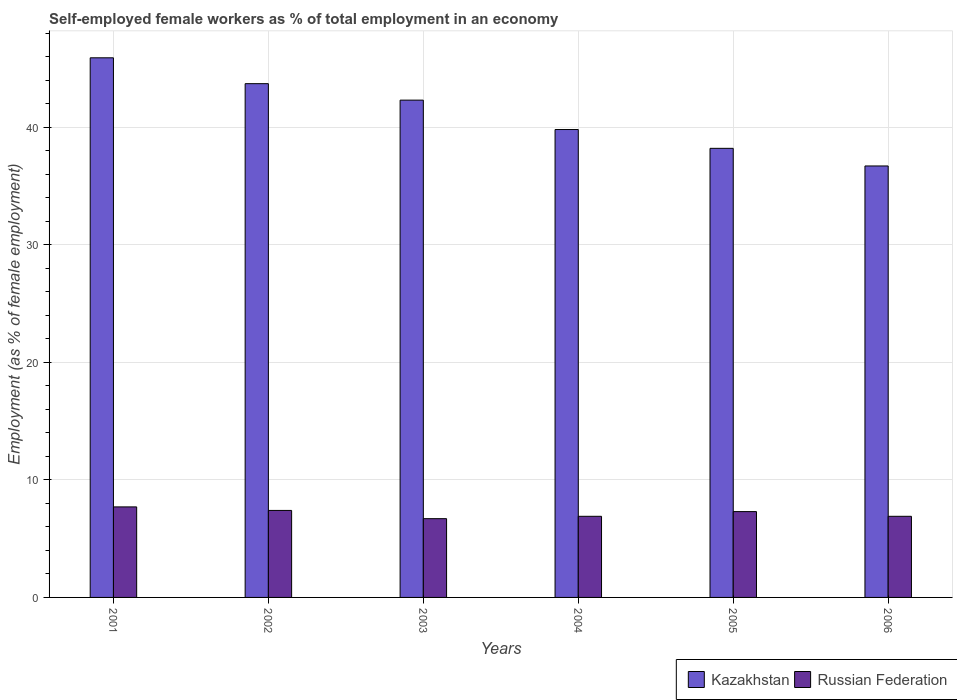How many different coloured bars are there?
Give a very brief answer. 2. How many bars are there on the 6th tick from the left?
Ensure brevity in your answer.  2. What is the percentage of self-employed female workers in Russian Federation in 2003?
Make the answer very short. 6.7. Across all years, what is the maximum percentage of self-employed female workers in Kazakhstan?
Ensure brevity in your answer.  45.9. Across all years, what is the minimum percentage of self-employed female workers in Russian Federation?
Provide a succinct answer. 6.7. In which year was the percentage of self-employed female workers in Kazakhstan maximum?
Your answer should be very brief. 2001. What is the total percentage of self-employed female workers in Kazakhstan in the graph?
Give a very brief answer. 246.6. What is the difference between the percentage of self-employed female workers in Russian Federation in 2001 and that in 2005?
Offer a very short reply. 0.4. What is the difference between the percentage of self-employed female workers in Russian Federation in 2005 and the percentage of self-employed female workers in Kazakhstan in 2006?
Your answer should be very brief. -29.4. What is the average percentage of self-employed female workers in Russian Federation per year?
Offer a terse response. 7.15. In the year 2002, what is the difference between the percentage of self-employed female workers in Russian Federation and percentage of self-employed female workers in Kazakhstan?
Your answer should be compact. -36.3. What is the ratio of the percentage of self-employed female workers in Kazakhstan in 2005 to that in 2006?
Your response must be concise. 1.04. What is the difference between the highest and the second highest percentage of self-employed female workers in Kazakhstan?
Your answer should be very brief. 2.2. What is the difference between the highest and the lowest percentage of self-employed female workers in Kazakhstan?
Ensure brevity in your answer.  9.2. In how many years, is the percentage of self-employed female workers in Kazakhstan greater than the average percentage of self-employed female workers in Kazakhstan taken over all years?
Give a very brief answer. 3. Is the sum of the percentage of self-employed female workers in Russian Federation in 2003 and 2006 greater than the maximum percentage of self-employed female workers in Kazakhstan across all years?
Your answer should be compact. No. What does the 2nd bar from the left in 2004 represents?
Your response must be concise. Russian Federation. What does the 2nd bar from the right in 2004 represents?
Keep it short and to the point. Kazakhstan. How many bars are there?
Provide a short and direct response. 12. What is the difference between two consecutive major ticks on the Y-axis?
Provide a succinct answer. 10. Are the values on the major ticks of Y-axis written in scientific E-notation?
Ensure brevity in your answer.  No. Does the graph contain any zero values?
Keep it short and to the point. No. Does the graph contain grids?
Ensure brevity in your answer.  Yes. Where does the legend appear in the graph?
Ensure brevity in your answer.  Bottom right. How many legend labels are there?
Your response must be concise. 2. What is the title of the graph?
Offer a terse response. Self-employed female workers as % of total employment in an economy. What is the label or title of the X-axis?
Give a very brief answer. Years. What is the label or title of the Y-axis?
Your answer should be compact. Employment (as % of female employment). What is the Employment (as % of female employment) of Kazakhstan in 2001?
Your answer should be compact. 45.9. What is the Employment (as % of female employment) in Russian Federation in 2001?
Give a very brief answer. 7.7. What is the Employment (as % of female employment) in Kazakhstan in 2002?
Offer a terse response. 43.7. What is the Employment (as % of female employment) of Russian Federation in 2002?
Keep it short and to the point. 7.4. What is the Employment (as % of female employment) in Kazakhstan in 2003?
Provide a succinct answer. 42.3. What is the Employment (as % of female employment) of Russian Federation in 2003?
Your answer should be very brief. 6.7. What is the Employment (as % of female employment) of Kazakhstan in 2004?
Keep it short and to the point. 39.8. What is the Employment (as % of female employment) in Russian Federation in 2004?
Your response must be concise. 6.9. What is the Employment (as % of female employment) in Kazakhstan in 2005?
Ensure brevity in your answer.  38.2. What is the Employment (as % of female employment) in Russian Federation in 2005?
Provide a succinct answer. 7.3. What is the Employment (as % of female employment) of Kazakhstan in 2006?
Keep it short and to the point. 36.7. What is the Employment (as % of female employment) of Russian Federation in 2006?
Offer a very short reply. 6.9. Across all years, what is the maximum Employment (as % of female employment) in Kazakhstan?
Your answer should be very brief. 45.9. Across all years, what is the maximum Employment (as % of female employment) of Russian Federation?
Your answer should be very brief. 7.7. Across all years, what is the minimum Employment (as % of female employment) of Kazakhstan?
Ensure brevity in your answer.  36.7. Across all years, what is the minimum Employment (as % of female employment) in Russian Federation?
Your answer should be compact. 6.7. What is the total Employment (as % of female employment) in Kazakhstan in the graph?
Your answer should be very brief. 246.6. What is the total Employment (as % of female employment) of Russian Federation in the graph?
Your answer should be compact. 42.9. What is the difference between the Employment (as % of female employment) in Russian Federation in 2001 and that in 2002?
Provide a succinct answer. 0.3. What is the difference between the Employment (as % of female employment) of Kazakhstan in 2001 and that in 2003?
Make the answer very short. 3.6. What is the difference between the Employment (as % of female employment) in Kazakhstan in 2001 and that in 2004?
Your answer should be compact. 6.1. What is the difference between the Employment (as % of female employment) in Kazakhstan in 2001 and that in 2005?
Your answer should be very brief. 7.7. What is the difference between the Employment (as % of female employment) of Kazakhstan in 2002 and that in 2003?
Keep it short and to the point. 1.4. What is the difference between the Employment (as % of female employment) in Russian Federation in 2002 and that in 2004?
Your answer should be very brief. 0.5. What is the difference between the Employment (as % of female employment) of Kazakhstan in 2002 and that in 2005?
Your response must be concise. 5.5. What is the difference between the Employment (as % of female employment) of Russian Federation in 2002 and that in 2005?
Give a very brief answer. 0.1. What is the difference between the Employment (as % of female employment) in Kazakhstan in 2002 and that in 2006?
Give a very brief answer. 7. What is the difference between the Employment (as % of female employment) of Russian Federation in 2002 and that in 2006?
Offer a very short reply. 0.5. What is the difference between the Employment (as % of female employment) in Kazakhstan in 2003 and that in 2004?
Offer a very short reply. 2.5. What is the difference between the Employment (as % of female employment) in Russian Federation in 2003 and that in 2004?
Ensure brevity in your answer.  -0.2. What is the difference between the Employment (as % of female employment) of Russian Federation in 2003 and that in 2005?
Provide a succinct answer. -0.6. What is the difference between the Employment (as % of female employment) of Russian Federation in 2003 and that in 2006?
Your response must be concise. -0.2. What is the difference between the Employment (as % of female employment) in Russian Federation in 2004 and that in 2006?
Give a very brief answer. 0. What is the difference between the Employment (as % of female employment) of Kazakhstan in 2005 and that in 2006?
Provide a succinct answer. 1.5. What is the difference between the Employment (as % of female employment) in Kazakhstan in 2001 and the Employment (as % of female employment) in Russian Federation in 2002?
Provide a succinct answer. 38.5. What is the difference between the Employment (as % of female employment) in Kazakhstan in 2001 and the Employment (as % of female employment) in Russian Federation in 2003?
Offer a terse response. 39.2. What is the difference between the Employment (as % of female employment) in Kazakhstan in 2001 and the Employment (as % of female employment) in Russian Federation in 2005?
Make the answer very short. 38.6. What is the difference between the Employment (as % of female employment) in Kazakhstan in 2002 and the Employment (as % of female employment) in Russian Federation in 2004?
Your answer should be very brief. 36.8. What is the difference between the Employment (as % of female employment) in Kazakhstan in 2002 and the Employment (as % of female employment) in Russian Federation in 2005?
Provide a succinct answer. 36.4. What is the difference between the Employment (as % of female employment) of Kazakhstan in 2002 and the Employment (as % of female employment) of Russian Federation in 2006?
Your response must be concise. 36.8. What is the difference between the Employment (as % of female employment) in Kazakhstan in 2003 and the Employment (as % of female employment) in Russian Federation in 2004?
Give a very brief answer. 35.4. What is the difference between the Employment (as % of female employment) in Kazakhstan in 2003 and the Employment (as % of female employment) in Russian Federation in 2006?
Offer a very short reply. 35.4. What is the difference between the Employment (as % of female employment) of Kazakhstan in 2004 and the Employment (as % of female employment) of Russian Federation in 2005?
Ensure brevity in your answer.  32.5. What is the difference between the Employment (as % of female employment) of Kazakhstan in 2004 and the Employment (as % of female employment) of Russian Federation in 2006?
Your response must be concise. 32.9. What is the difference between the Employment (as % of female employment) of Kazakhstan in 2005 and the Employment (as % of female employment) of Russian Federation in 2006?
Ensure brevity in your answer.  31.3. What is the average Employment (as % of female employment) in Kazakhstan per year?
Ensure brevity in your answer.  41.1. What is the average Employment (as % of female employment) of Russian Federation per year?
Give a very brief answer. 7.15. In the year 2001, what is the difference between the Employment (as % of female employment) in Kazakhstan and Employment (as % of female employment) in Russian Federation?
Make the answer very short. 38.2. In the year 2002, what is the difference between the Employment (as % of female employment) of Kazakhstan and Employment (as % of female employment) of Russian Federation?
Ensure brevity in your answer.  36.3. In the year 2003, what is the difference between the Employment (as % of female employment) of Kazakhstan and Employment (as % of female employment) of Russian Federation?
Your answer should be compact. 35.6. In the year 2004, what is the difference between the Employment (as % of female employment) in Kazakhstan and Employment (as % of female employment) in Russian Federation?
Ensure brevity in your answer.  32.9. In the year 2005, what is the difference between the Employment (as % of female employment) of Kazakhstan and Employment (as % of female employment) of Russian Federation?
Offer a very short reply. 30.9. In the year 2006, what is the difference between the Employment (as % of female employment) of Kazakhstan and Employment (as % of female employment) of Russian Federation?
Keep it short and to the point. 29.8. What is the ratio of the Employment (as % of female employment) in Kazakhstan in 2001 to that in 2002?
Keep it short and to the point. 1.05. What is the ratio of the Employment (as % of female employment) of Russian Federation in 2001 to that in 2002?
Offer a terse response. 1.04. What is the ratio of the Employment (as % of female employment) in Kazakhstan in 2001 to that in 2003?
Your response must be concise. 1.09. What is the ratio of the Employment (as % of female employment) of Russian Federation in 2001 to that in 2003?
Your answer should be very brief. 1.15. What is the ratio of the Employment (as % of female employment) of Kazakhstan in 2001 to that in 2004?
Ensure brevity in your answer.  1.15. What is the ratio of the Employment (as % of female employment) in Russian Federation in 2001 to that in 2004?
Your answer should be compact. 1.12. What is the ratio of the Employment (as % of female employment) of Kazakhstan in 2001 to that in 2005?
Offer a terse response. 1.2. What is the ratio of the Employment (as % of female employment) of Russian Federation in 2001 to that in 2005?
Your response must be concise. 1.05. What is the ratio of the Employment (as % of female employment) of Kazakhstan in 2001 to that in 2006?
Offer a terse response. 1.25. What is the ratio of the Employment (as % of female employment) of Russian Federation in 2001 to that in 2006?
Offer a terse response. 1.12. What is the ratio of the Employment (as % of female employment) in Kazakhstan in 2002 to that in 2003?
Ensure brevity in your answer.  1.03. What is the ratio of the Employment (as % of female employment) of Russian Federation in 2002 to that in 2003?
Provide a succinct answer. 1.1. What is the ratio of the Employment (as % of female employment) of Kazakhstan in 2002 to that in 2004?
Make the answer very short. 1.1. What is the ratio of the Employment (as % of female employment) in Russian Federation in 2002 to that in 2004?
Provide a succinct answer. 1.07. What is the ratio of the Employment (as % of female employment) of Kazakhstan in 2002 to that in 2005?
Your response must be concise. 1.14. What is the ratio of the Employment (as % of female employment) in Russian Federation in 2002 to that in 2005?
Ensure brevity in your answer.  1.01. What is the ratio of the Employment (as % of female employment) in Kazakhstan in 2002 to that in 2006?
Your response must be concise. 1.19. What is the ratio of the Employment (as % of female employment) of Russian Federation in 2002 to that in 2006?
Your answer should be compact. 1.07. What is the ratio of the Employment (as % of female employment) of Kazakhstan in 2003 to that in 2004?
Your answer should be very brief. 1.06. What is the ratio of the Employment (as % of female employment) of Russian Federation in 2003 to that in 2004?
Offer a terse response. 0.97. What is the ratio of the Employment (as % of female employment) of Kazakhstan in 2003 to that in 2005?
Your response must be concise. 1.11. What is the ratio of the Employment (as % of female employment) in Russian Federation in 2003 to that in 2005?
Provide a succinct answer. 0.92. What is the ratio of the Employment (as % of female employment) of Kazakhstan in 2003 to that in 2006?
Offer a terse response. 1.15. What is the ratio of the Employment (as % of female employment) in Russian Federation in 2003 to that in 2006?
Keep it short and to the point. 0.97. What is the ratio of the Employment (as % of female employment) of Kazakhstan in 2004 to that in 2005?
Ensure brevity in your answer.  1.04. What is the ratio of the Employment (as % of female employment) in Russian Federation in 2004 to that in 2005?
Make the answer very short. 0.95. What is the ratio of the Employment (as % of female employment) in Kazakhstan in 2004 to that in 2006?
Your answer should be compact. 1.08. What is the ratio of the Employment (as % of female employment) of Russian Federation in 2004 to that in 2006?
Your answer should be very brief. 1. What is the ratio of the Employment (as % of female employment) of Kazakhstan in 2005 to that in 2006?
Offer a terse response. 1.04. What is the ratio of the Employment (as % of female employment) in Russian Federation in 2005 to that in 2006?
Give a very brief answer. 1.06. What is the difference between the highest and the second highest Employment (as % of female employment) in Kazakhstan?
Keep it short and to the point. 2.2. What is the difference between the highest and the lowest Employment (as % of female employment) of Russian Federation?
Give a very brief answer. 1. 